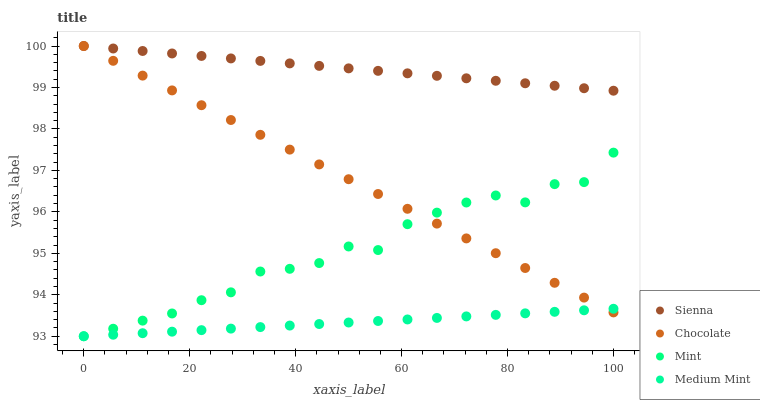Does Medium Mint have the minimum area under the curve?
Answer yes or no. Yes. Does Sienna have the maximum area under the curve?
Answer yes or no. Yes. Does Mint have the minimum area under the curve?
Answer yes or no. No. Does Mint have the maximum area under the curve?
Answer yes or no. No. Is Medium Mint the smoothest?
Answer yes or no. Yes. Is Mint the roughest?
Answer yes or no. Yes. Is Mint the smoothest?
Answer yes or no. No. Is Medium Mint the roughest?
Answer yes or no. No. Does Medium Mint have the lowest value?
Answer yes or no. Yes. Does Chocolate have the lowest value?
Answer yes or no. No. Does Chocolate have the highest value?
Answer yes or no. Yes. Does Mint have the highest value?
Answer yes or no. No. Is Mint less than Sienna?
Answer yes or no. Yes. Is Sienna greater than Mint?
Answer yes or no. Yes. Does Sienna intersect Chocolate?
Answer yes or no. Yes. Is Sienna less than Chocolate?
Answer yes or no. No. Is Sienna greater than Chocolate?
Answer yes or no. No. Does Mint intersect Sienna?
Answer yes or no. No. 